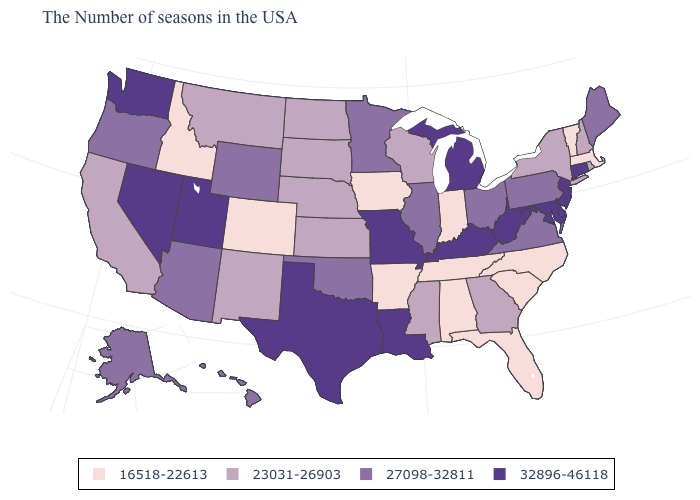Does Idaho have the lowest value in the West?
Be succinct. Yes. Name the states that have a value in the range 16518-22613?
Keep it brief. Massachusetts, Vermont, North Carolina, South Carolina, Florida, Indiana, Alabama, Tennessee, Arkansas, Iowa, Colorado, Idaho. Does the first symbol in the legend represent the smallest category?
Quick response, please. Yes. Name the states that have a value in the range 27098-32811?
Be succinct. Maine, Pennsylvania, Virginia, Ohio, Illinois, Minnesota, Oklahoma, Wyoming, Arizona, Oregon, Alaska, Hawaii. Among the states that border South Dakota , does Iowa have the highest value?
Concise answer only. No. What is the lowest value in states that border West Virginia?
Be succinct. 27098-32811. What is the lowest value in states that border Utah?
Short answer required. 16518-22613. What is the value of New Mexico?
Keep it brief. 23031-26903. Does the map have missing data?
Quick response, please. No. Which states have the highest value in the USA?
Quick response, please. Connecticut, New Jersey, Delaware, Maryland, West Virginia, Michigan, Kentucky, Louisiana, Missouri, Texas, Utah, Nevada, Washington. What is the value of New Jersey?
Concise answer only. 32896-46118. Does Minnesota have the highest value in the USA?
Be succinct. No. Which states have the highest value in the USA?
Give a very brief answer. Connecticut, New Jersey, Delaware, Maryland, West Virginia, Michigan, Kentucky, Louisiana, Missouri, Texas, Utah, Nevada, Washington. Name the states that have a value in the range 16518-22613?
Give a very brief answer. Massachusetts, Vermont, North Carolina, South Carolina, Florida, Indiana, Alabama, Tennessee, Arkansas, Iowa, Colorado, Idaho. Which states have the lowest value in the USA?
Give a very brief answer. Massachusetts, Vermont, North Carolina, South Carolina, Florida, Indiana, Alabama, Tennessee, Arkansas, Iowa, Colorado, Idaho. 